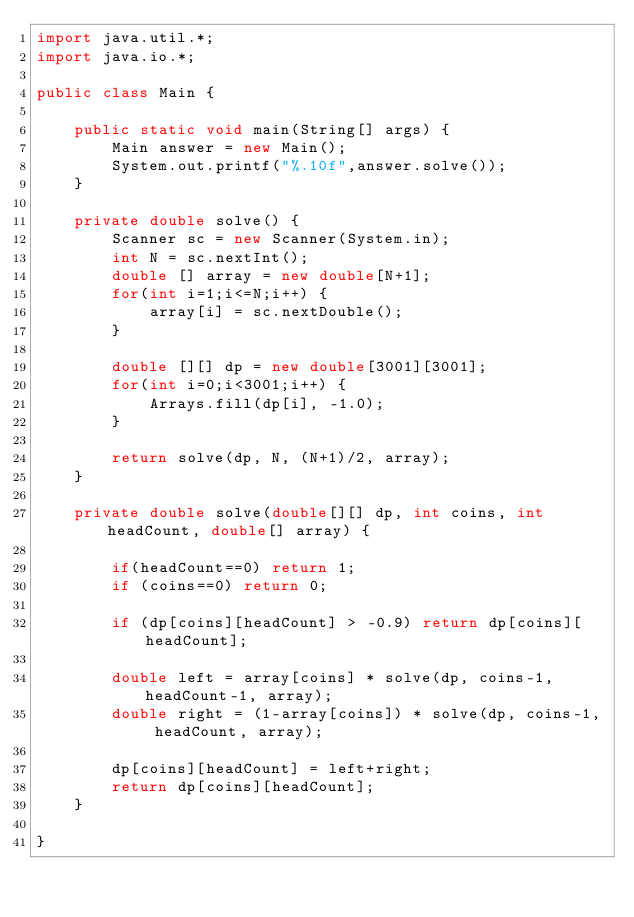Convert code to text. <code><loc_0><loc_0><loc_500><loc_500><_Java_>import java.util.*;
import java.io.*;

public class Main {

	public static void main(String[] args) {
		Main answer = new Main();
		System.out.printf("%.10f",answer.solve());
	}

	private double solve() {
		Scanner sc = new Scanner(System.in);
		int N = sc.nextInt();
		double [] array = new double[N+1];
		for(int i=1;i<=N;i++) {
			array[i] = sc.nextDouble();
		}

		double [][] dp = new double[3001][3001];
		for(int i=0;i<3001;i++) {
			Arrays.fill(dp[i], -1.0);
		}

		return solve(dp, N, (N+1)/2, array);
	}

	private double solve(double[][] dp, int coins, int headCount, double[] array) {

		if(headCount==0) return 1;
		if (coins==0) return 0;

		if (dp[coins][headCount] > -0.9) return dp[coins][headCount];

		double left = array[coins] * solve(dp, coins-1, headCount-1, array);
		double right = (1-array[coins]) * solve(dp, coins-1, headCount, array);

		dp[coins][headCount] = left+right;
		return dp[coins][headCount];
	}

}</code> 